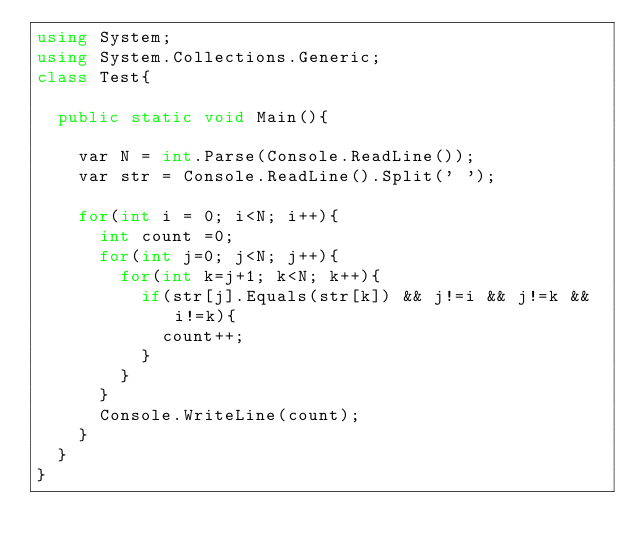<code> <loc_0><loc_0><loc_500><loc_500><_C#_>using System;
using System.Collections.Generic;
class Test{
 
  public static void Main(){
    
    var N = int.Parse(Console.ReadLine());
    var str = Console.ReadLine().Split(' ');
    
    for(int i = 0; i<N; i++){
      int count =0;
      for(int j=0; j<N; j++){
        for(int k=j+1; k<N; k++){
          if(str[j].Equals(str[k]) && j!=i && j!=k && i!=k){
            count++;
          }
        } 
      }
      Console.WriteLine(count);
    }
  }
}</code> 